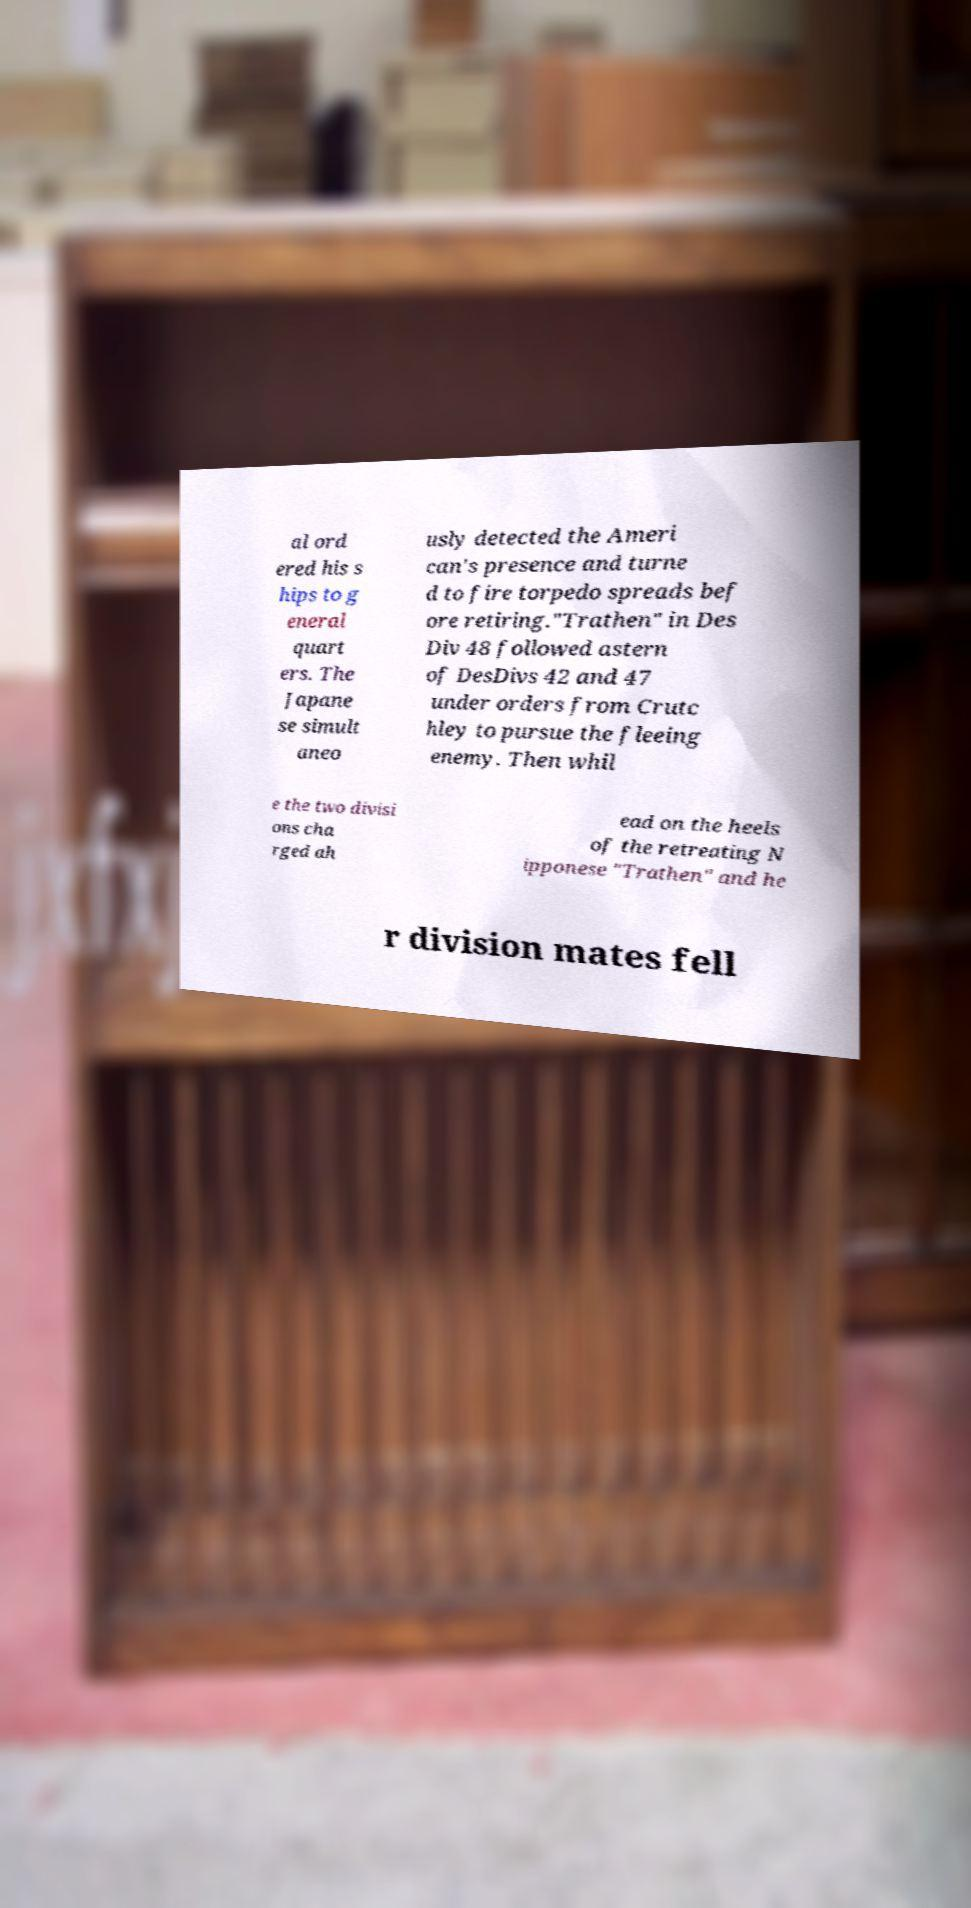Could you extract and type out the text from this image? al ord ered his s hips to g eneral quart ers. The Japane se simult aneo usly detected the Ameri can's presence and turne d to fire torpedo spreads bef ore retiring."Trathen" in Des Div 48 followed astern of DesDivs 42 and 47 under orders from Crutc hley to pursue the fleeing enemy. Then whil e the two divisi ons cha rged ah ead on the heels of the retreating N ipponese "Trathen" and he r division mates fell 